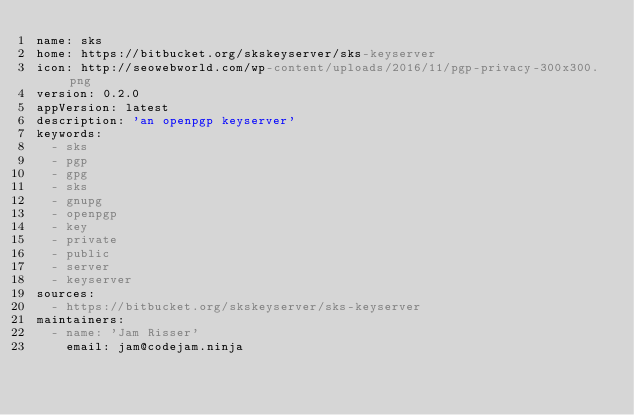Convert code to text. <code><loc_0><loc_0><loc_500><loc_500><_YAML_>name: sks
home: https://bitbucket.org/skskeyserver/sks-keyserver
icon: http://seowebworld.com/wp-content/uploads/2016/11/pgp-privacy-300x300.png
version: 0.2.0
appVersion: latest
description: 'an openpgp keyserver'
keywords:
  - sks
  - pgp
  - gpg
  - sks
  - gnupg
  - openpgp
  - key
  - private
  - public
  - server
  - keyserver
sources:
  - https://bitbucket.org/skskeyserver/sks-keyserver
maintainers:
  - name: 'Jam Risser'
    email: jam@codejam.ninja
</code> 